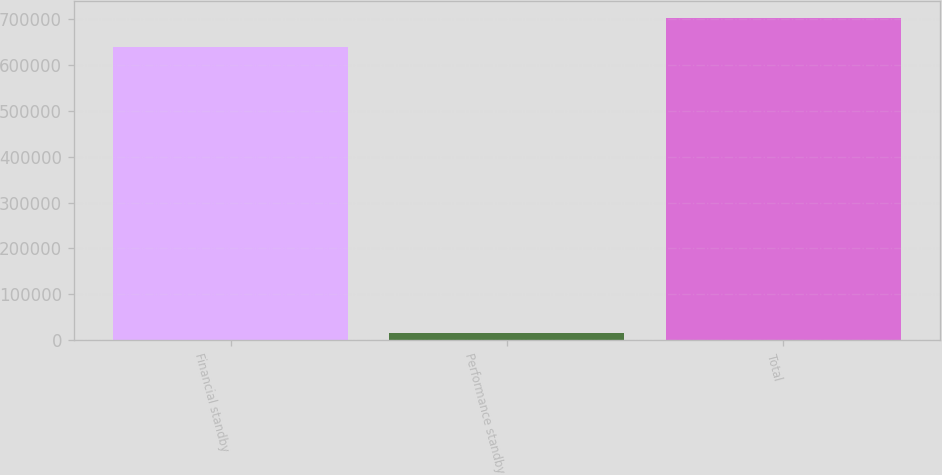Convert chart. <chart><loc_0><loc_0><loc_500><loc_500><bar_chart><fcel>Financial standby<fcel>Performance standby<fcel>Total<nl><fcel>637321<fcel>16970<fcel>702368<nl></chart> 